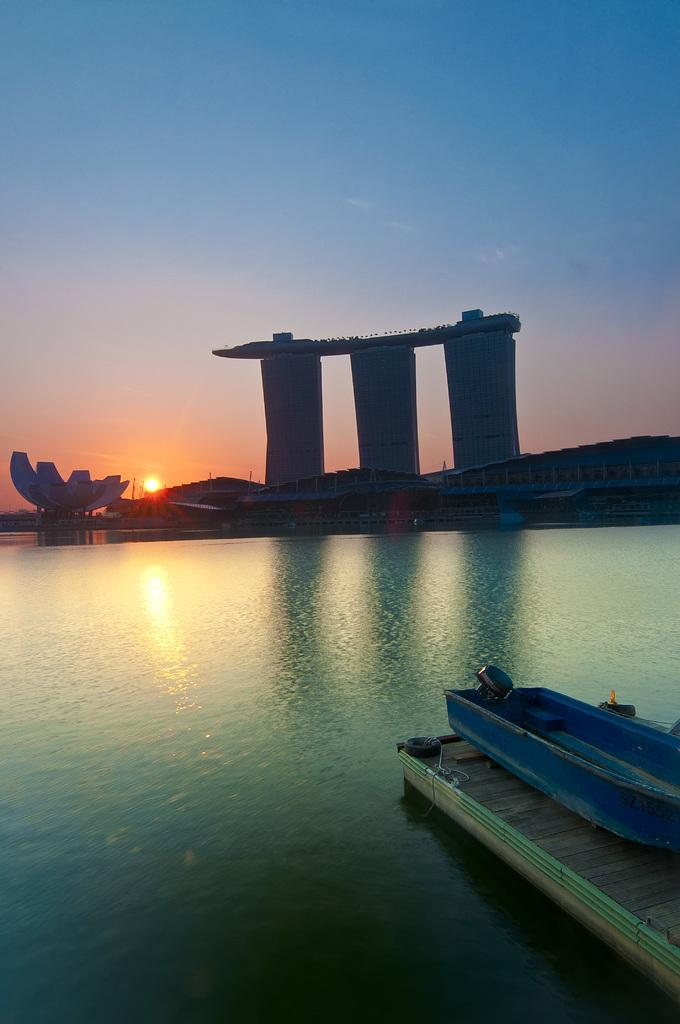What is the primary element visible in the image? There is water in the image. What structure can be seen crossing the water? There is a wooden bridge in the image. What type of vehicle is on the bridge? A blue colored boat is present on the bridge. What can be seen in the background of the image? There are buildings and the sky visible in the background of the image. Can the sun be seen in the sky? Yes, the sun is observable in the sky. What color crayon is being used to draw the clouds in the image? There are no clouds or crayons present in the image. Who is the creator of the wooden bridge in the image? The facts provided do not mention the creator of the wooden bridge, so it cannot be determined from the image. 